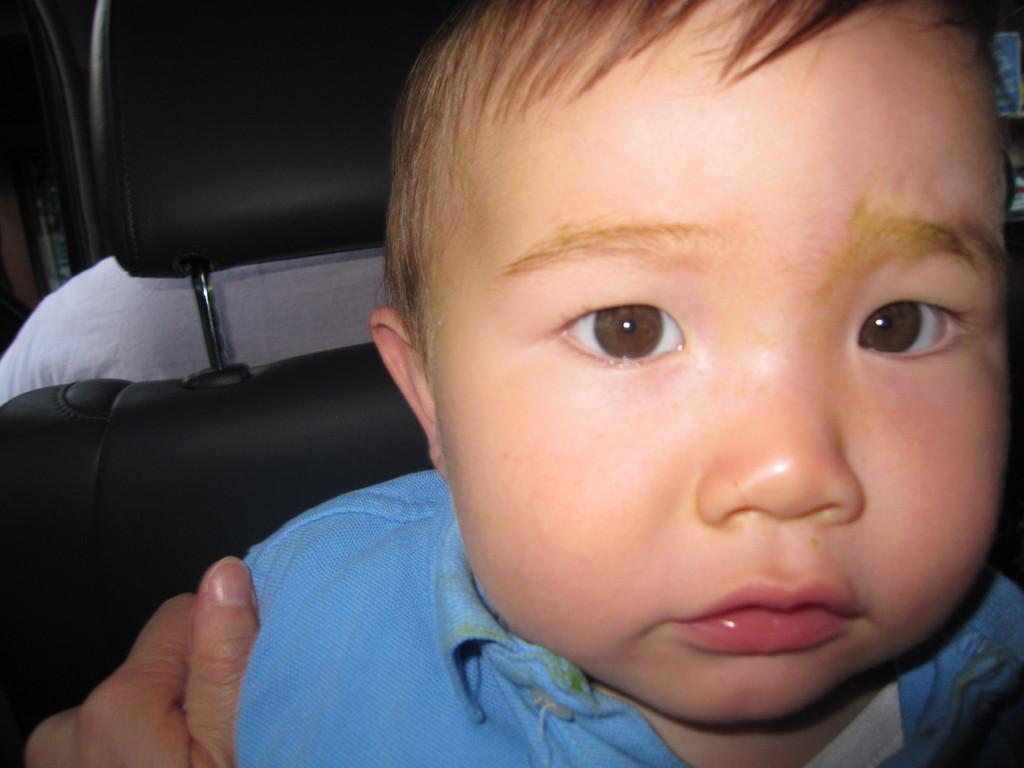Can you describe this image briefly? In this image a boy wearing a blue shirt. A person is holding the boy in his hand. Behind the boy there is a chair having a person sitting in it. 